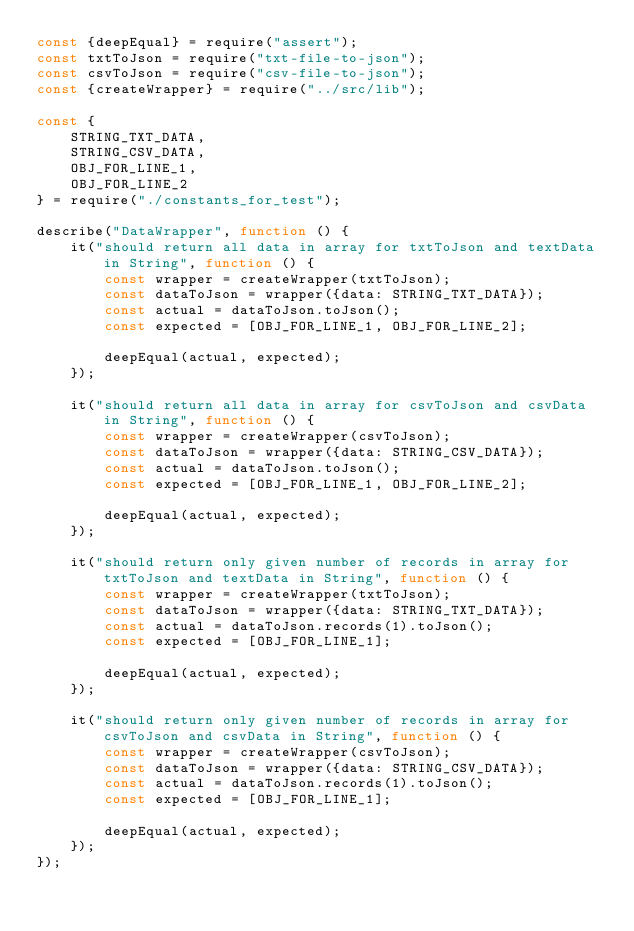Convert code to text. <code><loc_0><loc_0><loc_500><loc_500><_JavaScript_>const {deepEqual} = require("assert");
const txtToJson = require("txt-file-to-json");
const csvToJson = require("csv-file-to-json");
const {createWrapper} = require("../src/lib");

const {
    STRING_TXT_DATA,
    STRING_CSV_DATA,
    OBJ_FOR_LINE_1,
    OBJ_FOR_LINE_2
} = require("./constants_for_test");

describe("DataWrapper", function () {
    it("should return all data in array for txtToJson and textData in String", function () {
        const wrapper = createWrapper(txtToJson);
        const dataToJson = wrapper({data: STRING_TXT_DATA});
        const actual = dataToJson.toJson();
        const expected = [OBJ_FOR_LINE_1, OBJ_FOR_LINE_2];

        deepEqual(actual, expected);
    });

    it("should return all data in array for csvToJson and csvData in String", function () {
        const wrapper = createWrapper(csvToJson);
        const dataToJson = wrapper({data: STRING_CSV_DATA});
        const actual = dataToJson.toJson();
        const expected = [OBJ_FOR_LINE_1, OBJ_FOR_LINE_2];

        deepEqual(actual, expected);
    });

    it("should return only given number of records in array for txtToJson and textData in String", function () {
        const wrapper = createWrapper(txtToJson);
        const dataToJson = wrapper({data: STRING_TXT_DATA});
        const actual = dataToJson.records(1).toJson();
        const expected = [OBJ_FOR_LINE_1];

        deepEqual(actual, expected);
    });

    it("should return only given number of records in array for csvToJson and csvData in String", function () {
        const wrapper = createWrapper(csvToJson);
        const dataToJson = wrapper({data: STRING_CSV_DATA});
        const actual = dataToJson.records(1).toJson();
        const expected = [OBJ_FOR_LINE_1];

        deepEqual(actual, expected);
    });
});
</code> 